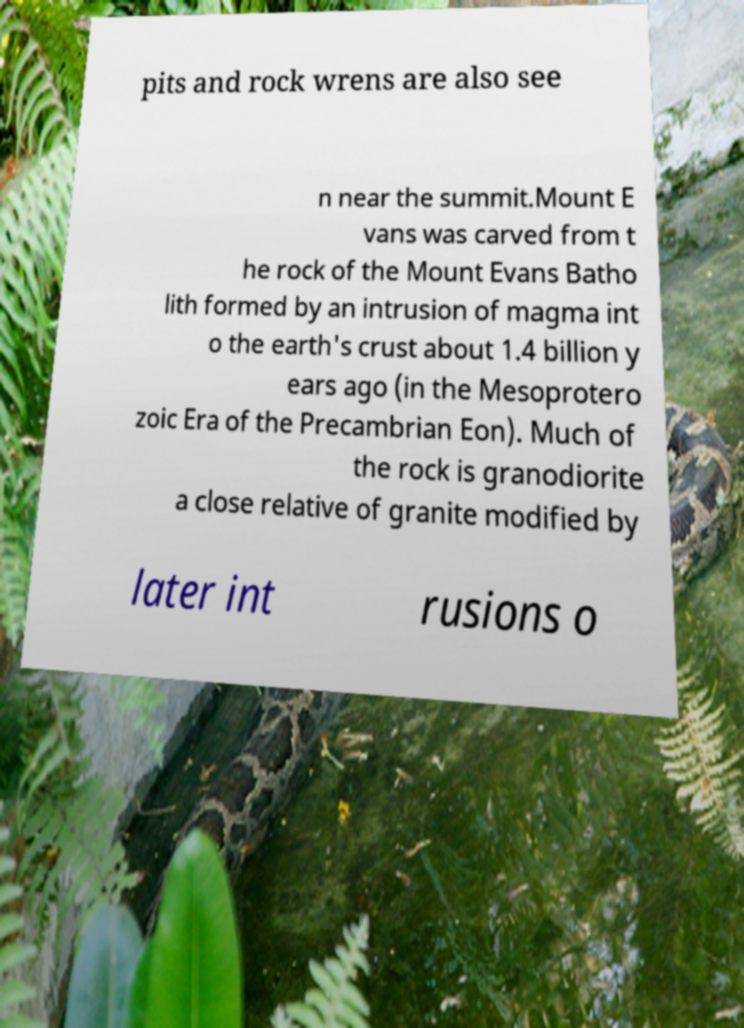Can you accurately transcribe the text from the provided image for me? pits and rock wrens are also see n near the summit.Mount E vans was carved from t he rock of the Mount Evans Batho lith formed by an intrusion of magma int o the earth's crust about 1.4 billion y ears ago (in the Mesoprotero zoic Era of the Precambrian Eon). Much of the rock is granodiorite a close relative of granite modified by later int rusions o 